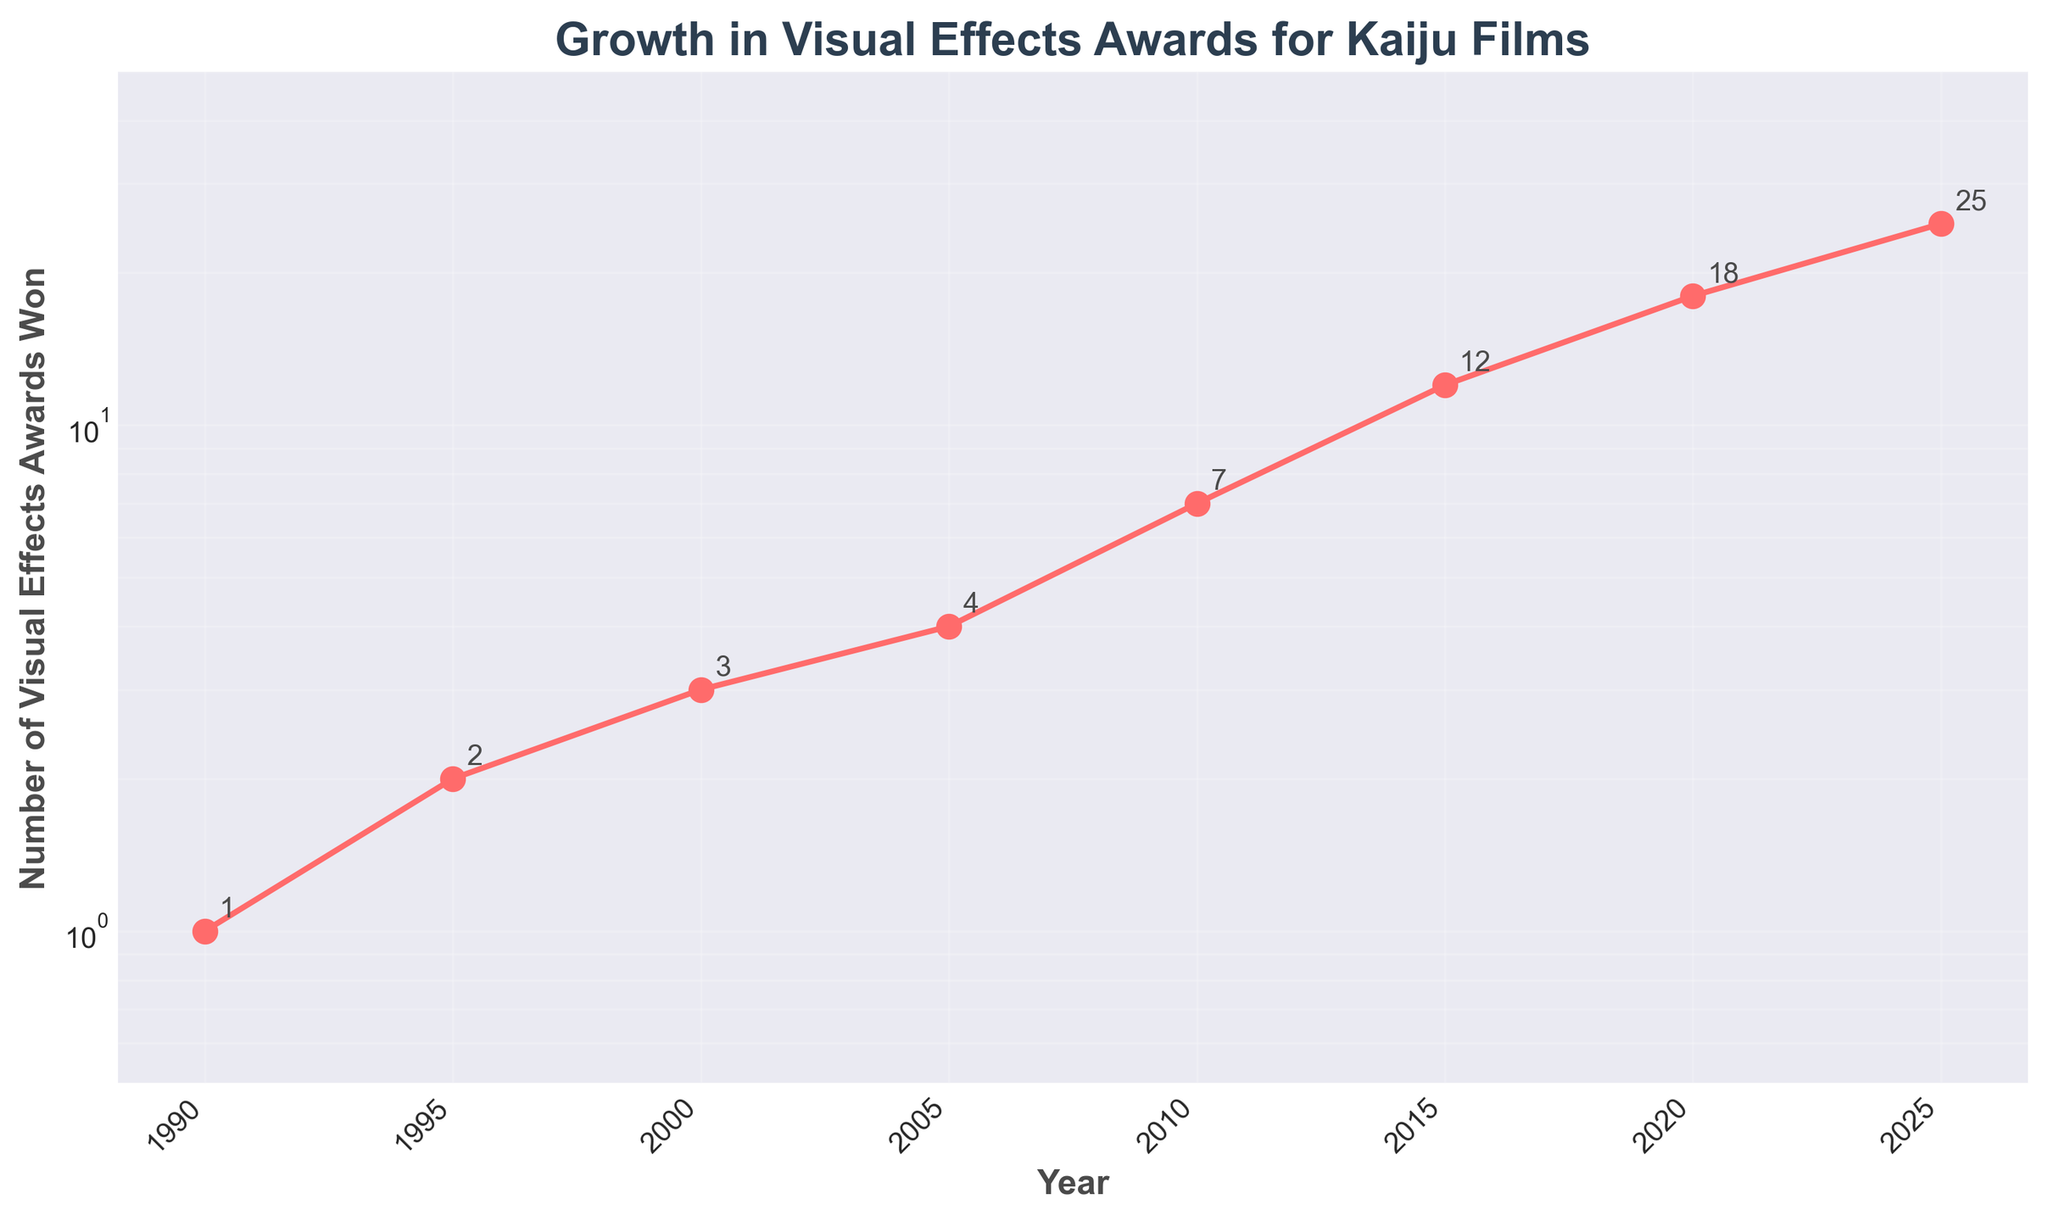what is the title of the figure? The title of a figure is typically placed at the top and intended to summarize the overall content. In this case, the title "Growth in Visual Effects Awards for Kaiju Films" is clearly displayed at the top of the plot.
Answer: Growth in Visual Effects Awards for Kaiju Films What is the highest number of visual effects awards won by kaiju films, and in which year? The highest number of visual effects awards can be found at the data point with the highest y-value. According to the plot, the highest number is 25, which occurred in 2025.
Answer: 25 in 2025 Describe the trend in the number of visual effects awards received by kaiju films from 1990 to 2025. By observing the plotted line, it is evident that the number of visual effects awards won by kaiju films is increasing steadily, and this trend accelerates after 2010. The line is upward, indicating continuous growth.
Answer: Increasing trend, accelerating after 2010 How many visual effects awards were won by kaiju films in 2005 compared to 2010? To compare the awards, look at the y-values corresponding to the x-values (years). In 2005, there are 4 awards, and in 2010, there are 7 awards. Perform a comparison between the two.
Answer: 4 in 2005, 7 in 2010 Which year saw the fastest growth in the number of visual effects awards? By looking at the steepest part of the line plot, especially with the log scale, the fastest growth is observed between 2010 and 2015, where the number of awards increased sharply from 7 to 12.
Answer: Between 2010 and 2015 On average, how many visual effects awards were won per decade? To calculate the average per decade, sum the values for each 10-year period and divide by the number of years. For instance, from 1990 to 2000, sum the awards (1+2+3), then divide by 10, and repeat for other decades.
Answer: 1.8 awards per decade approx What is the median number of visual effects awards won? The median is the middle value when the numbers are arranged in order. Arrange the data points (1, 2, 3, 4, 7, 12, 18, 25) and find the middle value.
Answer: 5.5 How does the number of awards in 1990 compare to the number in 1995 and 2000 combined? In 1990, kaiju films won 1 award. In 1995, they won 2 awards, and in 2000, they won 3 awards. Adding 1995 and 2000 gives 5, so compare 1 to 5.
Answer: 1 in 1990, 5 in 1995 + 2000 combined What is the difference between the number of awards won in 2015 and 2020? Look at the y-values for 2015 (12 awards) and 2020 (18 awards) and subtract the former from the latter.
Answer: Difference is 6 awards Does the figure indicate that kaiju films are more likely to receive visual effects awards now compared to the 1990s? Yes, by observing the steady increase over the years from 1990s to 2020s, it is evident that the number of awards has significantly increased, indicating higher likelihood.
Answer: Yes 